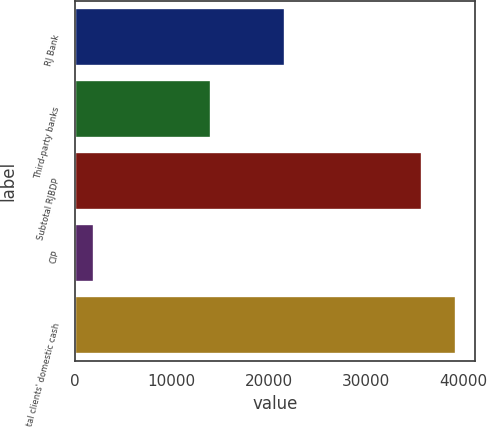<chart> <loc_0><loc_0><loc_500><loc_500><bar_chart><fcel>RJ Bank<fcel>Third-party banks<fcel>Subtotal RJBDP<fcel>CIP<fcel>Total clients' domestic cash<nl><fcel>21649<fcel>14043<fcel>35692<fcel>2022<fcel>39261.2<nl></chart> 